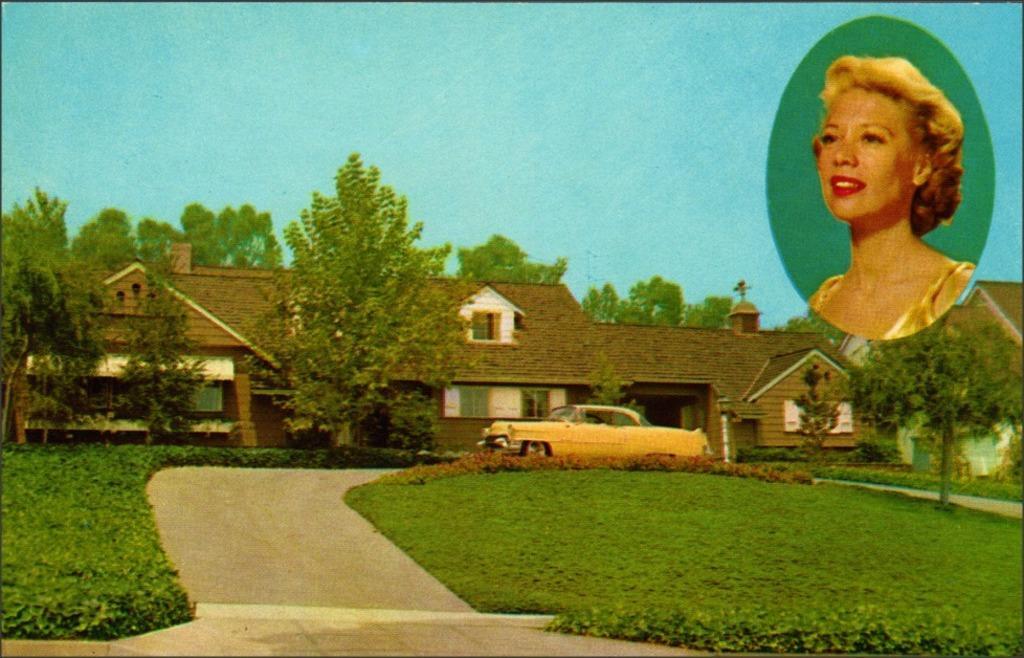Describe this image in one or two sentences. In this picture we can see a car, a building, trees and grass where, there is sky at the top of the picture, we can see a woman´s photo here. 